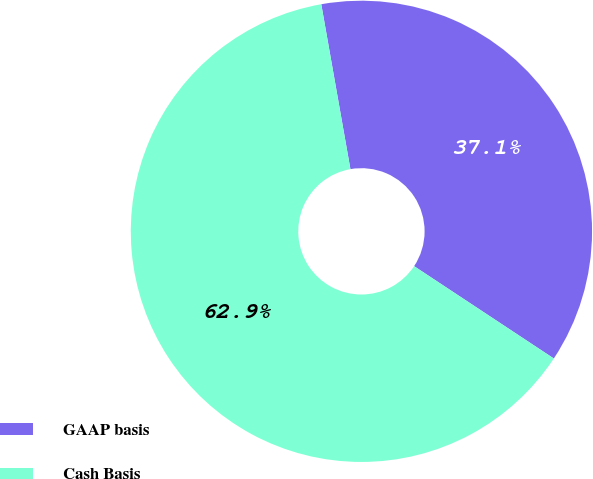<chart> <loc_0><loc_0><loc_500><loc_500><pie_chart><fcel>GAAP basis<fcel>Cash Basis<nl><fcel>37.08%<fcel>62.92%<nl></chart> 